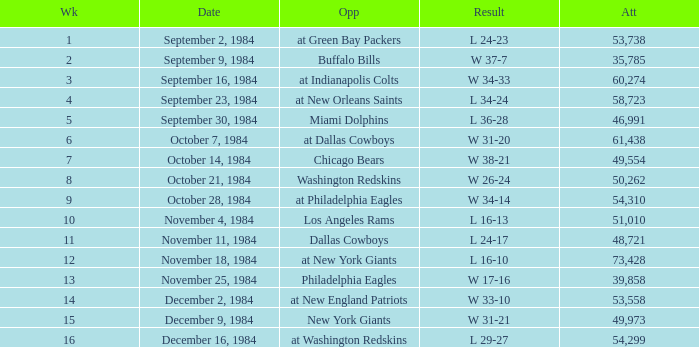Who was the opponent on October 14, 1984? Chicago Bears. 